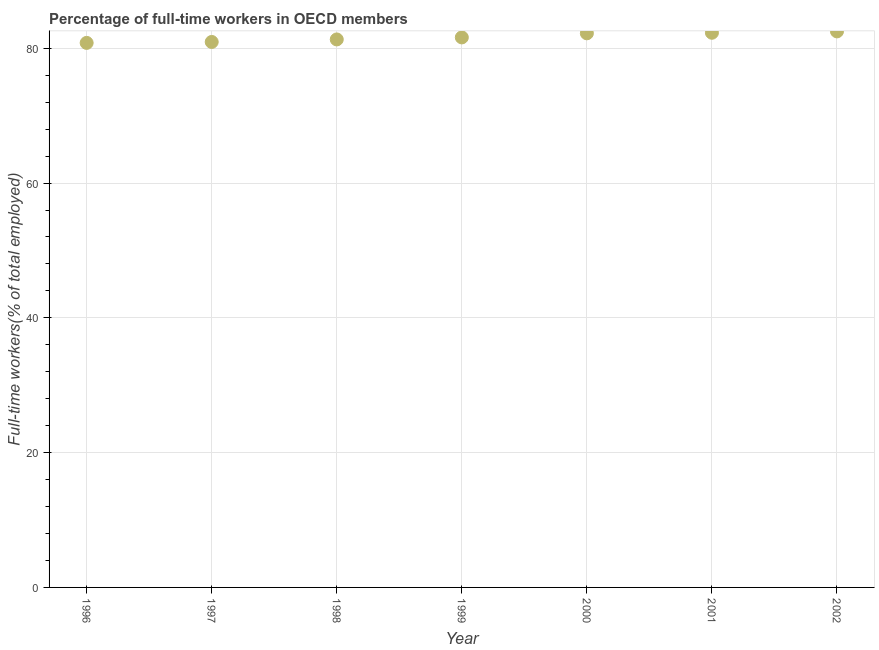What is the percentage of full-time workers in 1997?
Provide a short and direct response. 80.94. Across all years, what is the maximum percentage of full-time workers?
Your response must be concise. 82.5. Across all years, what is the minimum percentage of full-time workers?
Provide a short and direct response. 80.8. What is the sum of the percentage of full-time workers?
Make the answer very short. 571.68. What is the difference between the percentage of full-time workers in 1996 and 2001?
Your answer should be very brief. -1.5. What is the average percentage of full-time workers per year?
Offer a very short reply. 81.67. What is the median percentage of full-time workers?
Offer a very short reply. 81.61. In how many years, is the percentage of full-time workers greater than 64 %?
Ensure brevity in your answer.  7. Do a majority of the years between 1998 and 2002 (inclusive) have percentage of full-time workers greater than 20 %?
Ensure brevity in your answer.  Yes. What is the ratio of the percentage of full-time workers in 1996 to that in 1999?
Your answer should be compact. 0.99. Is the percentage of full-time workers in 1997 less than that in 2002?
Provide a short and direct response. Yes. What is the difference between the highest and the second highest percentage of full-time workers?
Your answer should be compact. 0.2. What is the difference between the highest and the lowest percentage of full-time workers?
Keep it short and to the point. 1.71. In how many years, is the percentage of full-time workers greater than the average percentage of full-time workers taken over all years?
Offer a terse response. 3. How many years are there in the graph?
Provide a succinct answer. 7. What is the title of the graph?
Ensure brevity in your answer.  Percentage of full-time workers in OECD members. What is the label or title of the Y-axis?
Your answer should be very brief. Full-time workers(% of total employed). What is the Full-time workers(% of total employed) in 1996?
Provide a succinct answer. 80.8. What is the Full-time workers(% of total employed) in 1997?
Your response must be concise. 80.94. What is the Full-time workers(% of total employed) in 1998?
Your answer should be compact. 81.31. What is the Full-time workers(% of total employed) in 1999?
Ensure brevity in your answer.  81.61. What is the Full-time workers(% of total employed) in 2000?
Offer a very short reply. 82.22. What is the Full-time workers(% of total employed) in 2001?
Make the answer very short. 82.3. What is the Full-time workers(% of total employed) in 2002?
Your answer should be compact. 82.5. What is the difference between the Full-time workers(% of total employed) in 1996 and 1997?
Give a very brief answer. -0.14. What is the difference between the Full-time workers(% of total employed) in 1996 and 1998?
Make the answer very short. -0.51. What is the difference between the Full-time workers(% of total employed) in 1996 and 1999?
Give a very brief answer. -0.81. What is the difference between the Full-time workers(% of total employed) in 1996 and 2000?
Provide a succinct answer. -1.42. What is the difference between the Full-time workers(% of total employed) in 1996 and 2001?
Your response must be concise. -1.5. What is the difference between the Full-time workers(% of total employed) in 1996 and 2002?
Offer a terse response. -1.71. What is the difference between the Full-time workers(% of total employed) in 1997 and 1998?
Offer a very short reply. -0.38. What is the difference between the Full-time workers(% of total employed) in 1997 and 1999?
Give a very brief answer. -0.67. What is the difference between the Full-time workers(% of total employed) in 1997 and 2000?
Your answer should be compact. -1.28. What is the difference between the Full-time workers(% of total employed) in 1997 and 2001?
Offer a very short reply. -1.36. What is the difference between the Full-time workers(% of total employed) in 1997 and 2002?
Provide a short and direct response. -1.57. What is the difference between the Full-time workers(% of total employed) in 1998 and 1999?
Your response must be concise. -0.3. What is the difference between the Full-time workers(% of total employed) in 1998 and 2000?
Your response must be concise. -0.91. What is the difference between the Full-time workers(% of total employed) in 1998 and 2001?
Give a very brief answer. -0.99. What is the difference between the Full-time workers(% of total employed) in 1998 and 2002?
Make the answer very short. -1.19. What is the difference between the Full-time workers(% of total employed) in 1999 and 2000?
Your response must be concise. -0.61. What is the difference between the Full-time workers(% of total employed) in 1999 and 2001?
Ensure brevity in your answer.  -0.69. What is the difference between the Full-time workers(% of total employed) in 1999 and 2002?
Offer a terse response. -0.89. What is the difference between the Full-time workers(% of total employed) in 2000 and 2001?
Provide a succinct answer. -0.08. What is the difference between the Full-time workers(% of total employed) in 2000 and 2002?
Your answer should be compact. -0.29. What is the difference between the Full-time workers(% of total employed) in 2001 and 2002?
Keep it short and to the point. -0.2. What is the ratio of the Full-time workers(% of total employed) in 1996 to that in 1997?
Offer a terse response. 1. What is the ratio of the Full-time workers(% of total employed) in 1996 to that in 1998?
Ensure brevity in your answer.  0.99. What is the ratio of the Full-time workers(% of total employed) in 1996 to that in 2000?
Your response must be concise. 0.98. What is the ratio of the Full-time workers(% of total employed) in 1996 to that in 2002?
Provide a succinct answer. 0.98. What is the ratio of the Full-time workers(% of total employed) in 1997 to that in 1998?
Ensure brevity in your answer.  0.99. What is the ratio of the Full-time workers(% of total employed) in 1997 to that in 1999?
Make the answer very short. 0.99. What is the ratio of the Full-time workers(% of total employed) in 1997 to that in 2001?
Ensure brevity in your answer.  0.98. What is the ratio of the Full-time workers(% of total employed) in 1998 to that in 1999?
Offer a terse response. 1. What is the ratio of the Full-time workers(% of total employed) in 1998 to that in 2001?
Give a very brief answer. 0.99. What is the ratio of the Full-time workers(% of total employed) in 1999 to that in 2002?
Your answer should be very brief. 0.99. What is the ratio of the Full-time workers(% of total employed) in 2000 to that in 2002?
Give a very brief answer. 1. What is the ratio of the Full-time workers(% of total employed) in 2001 to that in 2002?
Offer a very short reply. 1. 